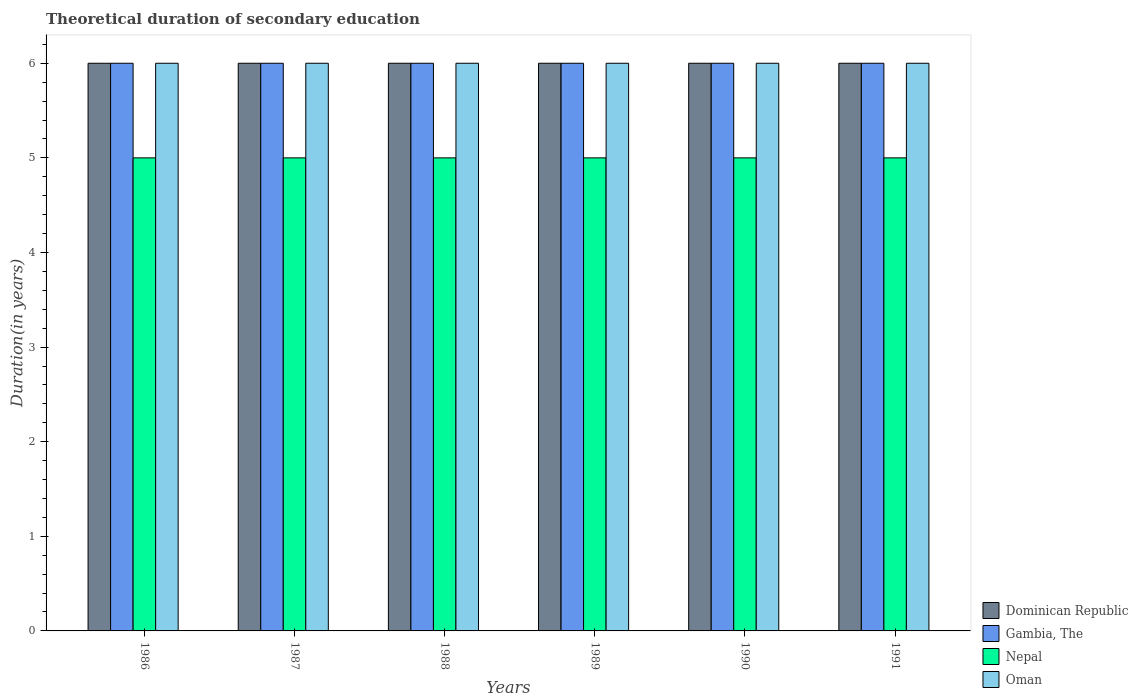How many different coloured bars are there?
Offer a very short reply. 4. How many groups of bars are there?
Ensure brevity in your answer.  6. How many bars are there on the 6th tick from the right?
Your response must be concise. 4. What is the label of the 6th group of bars from the left?
Keep it short and to the point. 1991. What is the total theoretical duration of secondary education in Gambia, The in 1990?
Make the answer very short. 6. Across all years, what is the maximum total theoretical duration of secondary education in Nepal?
Provide a succinct answer. 5. In which year was the total theoretical duration of secondary education in Oman minimum?
Ensure brevity in your answer.  1986. What is the total total theoretical duration of secondary education in Nepal in the graph?
Your answer should be compact. 30. What is the difference between the total theoretical duration of secondary education in Dominican Republic in 1987 and the total theoretical duration of secondary education in Nepal in 1990?
Make the answer very short. 1. What is the average total theoretical duration of secondary education in Dominican Republic per year?
Provide a succinct answer. 6. In the year 1986, what is the difference between the total theoretical duration of secondary education in Oman and total theoretical duration of secondary education in Nepal?
Provide a succinct answer. 1. In how many years, is the total theoretical duration of secondary education in Nepal greater than 4.2 years?
Offer a very short reply. 6. Is the total theoretical duration of secondary education in Nepal in 1986 less than that in 1988?
Your answer should be compact. No. What is the difference between the highest and the second highest total theoretical duration of secondary education in Oman?
Your answer should be compact. 0. What is the difference between the highest and the lowest total theoretical duration of secondary education in Gambia, The?
Your answer should be compact. 0. In how many years, is the total theoretical duration of secondary education in Nepal greater than the average total theoretical duration of secondary education in Nepal taken over all years?
Ensure brevity in your answer.  0. Is the sum of the total theoretical duration of secondary education in Dominican Republic in 1986 and 1988 greater than the maximum total theoretical duration of secondary education in Gambia, The across all years?
Your answer should be compact. Yes. What does the 4th bar from the left in 1991 represents?
Your answer should be compact. Oman. What does the 3rd bar from the right in 1990 represents?
Your answer should be compact. Gambia, The. How many bars are there?
Provide a short and direct response. 24. Are all the bars in the graph horizontal?
Provide a short and direct response. No. How many years are there in the graph?
Give a very brief answer. 6. Does the graph contain any zero values?
Your answer should be very brief. No. How are the legend labels stacked?
Give a very brief answer. Vertical. What is the title of the graph?
Give a very brief answer. Theoretical duration of secondary education. What is the label or title of the X-axis?
Make the answer very short. Years. What is the label or title of the Y-axis?
Your answer should be very brief. Duration(in years). What is the Duration(in years) of Gambia, The in 1986?
Your answer should be very brief. 6. What is the Duration(in years) of Dominican Republic in 1987?
Offer a very short reply. 6. What is the Duration(in years) in Gambia, The in 1987?
Your answer should be very brief. 6. What is the Duration(in years) in Nepal in 1987?
Your response must be concise. 5. What is the Duration(in years) of Gambia, The in 1988?
Offer a terse response. 6. What is the Duration(in years) of Oman in 1988?
Keep it short and to the point. 6. What is the Duration(in years) in Gambia, The in 1989?
Your answer should be compact. 6. What is the Duration(in years) in Nepal in 1989?
Give a very brief answer. 5. What is the Duration(in years) in Oman in 1989?
Provide a succinct answer. 6. What is the Duration(in years) in Dominican Republic in 1990?
Offer a terse response. 6. What is the Duration(in years) in Gambia, The in 1990?
Provide a succinct answer. 6. What is the Duration(in years) in Nepal in 1991?
Give a very brief answer. 5. Across all years, what is the maximum Duration(in years) in Dominican Republic?
Offer a very short reply. 6. Across all years, what is the maximum Duration(in years) in Gambia, The?
Provide a short and direct response. 6. Across all years, what is the maximum Duration(in years) in Nepal?
Ensure brevity in your answer.  5. Across all years, what is the minimum Duration(in years) in Gambia, The?
Provide a short and direct response. 6. What is the total Duration(in years) in Gambia, The in the graph?
Offer a very short reply. 36. What is the total Duration(in years) in Oman in the graph?
Make the answer very short. 36. What is the difference between the Duration(in years) of Gambia, The in 1986 and that in 1987?
Offer a terse response. 0. What is the difference between the Duration(in years) in Oman in 1986 and that in 1987?
Your response must be concise. 0. What is the difference between the Duration(in years) in Dominican Republic in 1986 and that in 1988?
Ensure brevity in your answer.  0. What is the difference between the Duration(in years) in Gambia, The in 1986 and that in 1988?
Provide a short and direct response. 0. What is the difference between the Duration(in years) in Oman in 1986 and that in 1988?
Your answer should be very brief. 0. What is the difference between the Duration(in years) in Dominican Republic in 1986 and that in 1989?
Make the answer very short. 0. What is the difference between the Duration(in years) in Gambia, The in 1986 and that in 1989?
Make the answer very short. 0. What is the difference between the Duration(in years) in Oman in 1986 and that in 1989?
Your answer should be very brief. 0. What is the difference between the Duration(in years) of Dominican Republic in 1986 and that in 1990?
Provide a short and direct response. 0. What is the difference between the Duration(in years) in Nepal in 1986 and that in 1990?
Provide a succinct answer. 0. What is the difference between the Duration(in years) in Oman in 1986 and that in 1990?
Offer a terse response. 0. What is the difference between the Duration(in years) of Dominican Republic in 1986 and that in 1991?
Keep it short and to the point. 0. What is the difference between the Duration(in years) of Gambia, The in 1986 and that in 1991?
Your answer should be very brief. 0. What is the difference between the Duration(in years) of Dominican Republic in 1987 and that in 1989?
Ensure brevity in your answer.  0. What is the difference between the Duration(in years) of Gambia, The in 1987 and that in 1991?
Keep it short and to the point. 0. What is the difference between the Duration(in years) of Nepal in 1987 and that in 1991?
Make the answer very short. 0. What is the difference between the Duration(in years) of Oman in 1987 and that in 1991?
Your answer should be compact. 0. What is the difference between the Duration(in years) of Gambia, The in 1988 and that in 1989?
Keep it short and to the point. 0. What is the difference between the Duration(in years) in Gambia, The in 1988 and that in 1990?
Provide a short and direct response. 0. What is the difference between the Duration(in years) in Oman in 1988 and that in 1990?
Provide a short and direct response. 0. What is the difference between the Duration(in years) of Gambia, The in 1988 and that in 1991?
Offer a terse response. 0. What is the difference between the Duration(in years) in Oman in 1988 and that in 1991?
Your answer should be compact. 0. What is the difference between the Duration(in years) in Nepal in 1989 and that in 1990?
Your response must be concise. 0. What is the difference between the Duration(in years) of Oman in 1989 and that in 1991?
Your answer should be very brief. 0. What is the difference between the Duration(in years) of Dominican Republic in 1990 and that in 1991?
Make the answer very short. 0. What is the difference between the Duration(in years) in Gambia, The in 1990 and that in 1991?
Provide a succinct answer. 0. What is the difference between the Duration(in years) in Oman in 1990 and that in 1991?
Your response must be concise. 0. What is the difference between the Duration(in years) of Dominican Republic in 1986 and the Duration(in years) of Gambia, The in 1987?
Provide a short and direct response. 0. What is the difference between the Duration(in years) of Dominican Republic in 1986 and the Duration(in years) of Nepal in 1987?
Provide a short and direct response. 1. What is the difference between the Duration(in years) of Gambia, The in 1986 and the Duration(in years) of Nepal in 1987?
Make the answer very short. 1. What is the difference between the Duration(in years) in Nepal in 1986 and the Duration(in years) in Oman in 1987?
Your answer should be compact. -1. What is the difference between the Duration(in years) of Dominican Republic in 1986 and the Duration(in years) of Oman in 1988?
Ensure brevity in your answer.  0. What is the difference between the Duration(in years) in Gambia, The in 1986 and the Duration(in years) in Oman in 1988?
Provide a succinct answer. 0. What is the difference between the Duration(in years) in Nepal in 1986 and the Duration(in years) in Oman in 1988?
Give a very brief answer. -1. What is the difference between the Duration(in years) of Dominican Republic in 1986 and the Duration(in years) of Gambia, The in 1989?
Provide a succinct answer. 0. What is the difference between the Duration(in years) of Gambia, The in 1986 and the Duration(in years) of Oman in 1990?
Give a very brief answer. 0. What is the difference between the Duration(in years) in Dominican Republic in 1986 and the Duration(in years) in Gambia, The in 1991?
Your response must be concise. 0. What is the difference between the Duration(in years) in Dominican Republic in 1986 and the Duration(in years) in Nepal in 1991?
Ensure brevity in your answer.  1. What is the difference between the Duration(in years) in Gambia, The in 1986 and the Duration(in years) in Oman in 1991?
Offer a very short reply. 0. What is the difference between the Duration(in years) of Nepal in 1986 and the Duration(in years) of Oman in 1991?
Provide a short and direct response. -1. What is the difference between the Duration(in years) of Dominican Republic in 1987 and the Duration(in years) of Gambia, The in 1988?
Keep it short and to the point. 0. What is the difference between the Duration(in years) of Dominican Republic in 1987 and the Duration(in years) of Nepal in 1988?
Your answer should be very brief. 1. What is the difference between the Duration(in years) in Dominican Republic in 1987 and the Duration(in years) in Oman in 1988?
Your answer should be compact. 0. What is the difference between the Duration(in years) of Gambia, The in 1987 and the Duration(in years) of Nepal in 1988?
Make the answer very short. 1. What is the difference between the Duration(in years) of Nepal in 1987 and the Duration(in years) of Oman in 1988?
Give a very brief answer. -1. What is the difference between the Duration(in years) of Dominican Republic in 1987 and the Duration(in years) of Nepal in 1989?
Keep it short and to the point. 1. What is the difference between the Duration(in years) in Dominican Republic in 1987 and the Duration(in years) in Oman in 1989?
Your answer should be very brief. 0. What is the difference between the Duration(in years) in Gambia, The in 1987 and the Duration(in years) in Oman in 1989?
Make the answer very short. 0. What is the difference between the Duration(in years) of Dominican Republic in 1987 and the Duration(in years) of Nepal in 1990?
Your answer should be compact. 1. What is the difference between the Duration(in years) of Dominican Republic in 1987 and the Duration(in years) of Oman in 1990?
Make the answer very short. 0. What is the difference between the Duration(in years) of Gambia, The in 1987 and the Duration(in years) of Oman in 1990?
Provide a succinct answer. 0. What is the difference between the Duration(in years) in Nepal in 1987 and the Duration(in years) in Oman in 1990?
Ensure brevity in your answer.  -1. What is the difference between the Duration(in years) in Gambia, The in 1987 and the Duration(in years) in Nepal in 1991?
Give a very brief answer. 1. What is the difference between the Duration(in years) of Dominican Republic in 1988 and the Duration(in years) of Gambia, The in 1989?
Make the answer very short. 0. What is the difference between the Duration(in years) of Dominican Republic in 1988 and the Duration(in years) of Oman in 1989?
Provide a succinct answer. 0. What is the difference between the Duration(in years) of Gambia, The in 1988 and the Duration(in years) of Oman in 1989?
Keep it short and to the point. 0. What is the difference between the Duration(in years) of Dominican Republic in 1988 and the Duration(in years) of Gambia, The in 1990?
Offer a very short reply. 0. What is the difference between the Duration(in years) in Dominican Republic in 1988 and the Duration(in years) in Oman in 1990?
Provide a short and direct response. 0. What is the difference between the Duration(in years) in Gambia, The in 1988 and the Duration(in years) in Nepal in 1990?
Provide a succinct answer. 1. What is the difference between the Duration(in years) of Nepal in 1988 and the Duration(in years) of Oman in 1990?
Your response must be concise. -1. What is the difference between the Duration(in years) in Nepal in 1988 and the Duration(in years) in Oman in 1991?
Your answer should be very brief. -1. What is the difference between the Duration(in years) of Gambia, The in 1989 and the Duration(in years) of Nepal in 1990?
Your answer should be very brief. 1. What is the difference between the Duration(in years) of Gambia, The in 1989 and the Duration(in years) of Oman in 1990?
Keep it short and to the point. 0. What is the difference between the Duration(in years) of Dominican Republic in 1989 and the Duration(in years) of Gambia, The in 1991?
Keep it short and to the point. 0. What is the difference between the Duration(in years) of Dominican Republic in 1989 and the Duration(in years) of Nepal in 1991?
Ensure brevity in your answer.  1. What is the difference between the Duration(in years) of Dominican Republic in 1989 and the Duration(in years) of Oman in 1991?
Keep it short and to the point. 0. What is the difference between the Duration(in years) of Gambia, The in 1989 and the Duration(in years) of Nepal in 1991?
Provide a succinct answer. 1. What is the difference between the Duration(in years) in Gambia, The in 1989 and the Duration(in years) in Oman in 1991?
Provide a short and direct response. 0. What is the difference between the Duration(in years) in Nepal in 1989 and the Duration(in years) in Oman in 1991?
Offer a very short reply. -1. What is the difference between the Duration(in years) of Dominican Republic in 1990 and the Duration(in years) of Gambia, The in 1991?
Ensure brevity in your answer.  0. What is the difference between the Duration(in years) of Dominican Republic in 1990 and the Duration(in years) of Nepal in 1991?
Make the answer very short. 1. What is the difference between the Duration(in years) in Gambia, The in 1990 and the Duration(in years) in Nepal in 1991?
Your answer should be compact. 1. What is the difference between the Duration(in years) of Nepal in 1990 and the Duration(in years) of Oman in 1991?
Ensure brevity in your answer.  -1. What is the average Duration(in years) in Gambia, The per year?
Ensure brevity in your answer.  6. What is the average Duration(in years) in Nepal per year?
Ensure brevity in your answer.  5. In the year 1986, what is the difference between the Duration(in years) in Dominican Republic and Duration(in years) in Oman?
Your response must be concise. 0. In the year 1986, what is the difference between the Duration(in years) in Gambia, The and Duration(in years) in Nepal?
Make the answer very short. 1. In the year 1986, what is the difference between the Duration(in years) of Nepal and Duration(in years) of Oman?
Provide a short and direct response. -1. In the year 1987, what is the difference between the Duration(in years) in Dominican Republic and Duration(in years) in Nepal?
Provide a short and direct response. 1. In the year 1987, what is the difference between the Duration(in years) in Gambia, The and Duration(in years) in Nepal?
Offer a very short reply. 1. In the year 1987, what is the difference between the Duration(in years) of Gambia, The and Duration(in years) of Oman?
Provide a succinct answer. 0. In the year 1987, what is the difference between the Duration(in years) in Nepal and Duration(in years) in Oman?
Offer a very short reply. -1. In the year 1988, what is the difference between the Duration(in years) of Dominican Republic and Duration(in years) of Nepal?
Offer a very short reply. 1. In the year 1988, what is the difference between the Duration(in years) of Nepal and Duration(in years) of Oman?
Ensure brevity in your answer.  -1. In the year 1989, what is the difference between the Duration(in years) in Dominican Republic and Duration(in years) in Gambia, The?
Ensure brevity in your answer.  0. In the year 1989, what is the difference between the Duration(in years) of Dominican Republic and Duration(in years) of Nepal?
Your response must be concise. 1. In the year 1989, what is the difference between the Duration(in years) in Gambia, The and Duration(in years) in Nepal?
Your answer should be compact. 1. In the year 1989, what is the difference between the Duration(in years) in Gambia, The and Duration(in years) in Oman?
Provide a succinct answer. 0. In the year 1989, what is the difference between the Duration(in years) of Nepal and Duration(in years) of Oman?
Provide a short and direct response. -1. In the year 1990, what is the difference between the Duration(in years) in Dominican Republic and Duration(in years) in Gambia, The?
Offer a very short reply. 0. In the year 1990, what is the difference between the Duration(in years) in Dominican Republic and Duration(in years) in Nepal?
Give a very brief answer. 1. In the year 1990, what is the difference between the Duration(in years) of Dominican Republic and Duration(in years) of Oman?
Your response must be concise. 0. In the year 1990, what is the difference between the Duration(in years) of Gambia, The and Duration(in years) of Nepal?
Offer a very short reply. 1. In the year 1990, what is the difference between the Duration(in years) in Gambia, The and Duration(in years) in Oman?
Offer a very short reply. 0. In the year 1990, what is the difference between the Duration(in years) of Nepal and Duration(in years) of Oman?
Offer a very short reply. -1. In the year 1991, what is the difference between the Duration(in years) in Dominican Republic and Duration(in years) in Nepal?
Your answer should be compact. 1. In the year 1991, what is the difference between the Duration(in years) in Dominican Republic and Duration(in years) in Oman?
Your answer should be very brief. 0. In the year 1991, what is the difference between the Duration(in years) of Gambia, The and Duration(in years) of Nepal?
Provide a short and direct response. 1. In the year 1991, what is the difference between the Duration(in years) in Gambia, The and Duration(in years) in Oman?
Provide a short and direct response. 0. In the year 1991, what is the difference between the Duration(in years) of Nepal and Duration(in years) of Oman?
Give a very brief answer. -1. What is the ratio of the Duration(in years) in Dominican Republic in 1986 to that in 1987?
Provide a short and direct response. 1. What is the ratio of the Duration(in years) in Nepal in 1986 to that in 1987?
Offer a terse response. 1. What is the ratio of the Duration(in years) in Gambia, The in 1986 to that in 1988?
Provide a short and direct response. 1. What is the ratio of the Duration(in years) of Dominican Republic in 1986 to that in 1989?
Ensure brevity in your answer.  1. What is the ratio of the Duration(in years) of Nepal in 1986 to that in 1989?
Make the answer very short. 1. What is the ratio of the Duration(in years) of Dominican Republic in 1986 to that in 1990?
Your answer should be very brief. 1. What is the ratio of the Duration(in years) in Oman in 1986 to that in 1990?
Your response must be concise. 1. What is the ratio of the Duration(in years) of Dominican Republic in 1986 to that in 1991?
Your answer should be compact. 1. What is the ratio of the Duration(in years) of Gambia, The in 1987 to that in 1988?
Keep it short and to the point. 1. What is the ratio of the Duration(in years) of Nepal in 1987 to that in 1988?
Provide a succinct answer. 1. What is the ratio of the Duration(in years) in Oman in 1987 to that in 1988?
Keep it short and to the point. 1. What is the ratio of the Duration(in years) of Dominican Republic in 1987 to that in 1989?
Give a very brief answer. 1. What is the ratio of the Duration(in years) in Gambia, The in 1987 to that in 1989?
Provide a short and direct response. 1. What is the ratio of the Duration(in years) of Nepal in 1987 to that in 1989?
Give a very brief answer. 1. What is the ratio of the Duration(in years) in Dominican Republic in 1987 to that in 1990?
Offer a terse response. 1. What is the ratio of the Duration(in years) of Gambia, The in 1987 to that in 1990?
Give a very brief answer. 1. What is the ratio of the Duration(in years) in Nepal in 1987 to that in 1991?
Your answer should be very brief. 1. What is the ratio of the Duration(in years) of Oman in 1987 to that in 1991?
Offer a terse response. 1. What is the ratio of the Duration(in years) in Dominican Republic in 1988 to that in 1989?
Provide a succinct answer. 1. What is the ratio of the Duration(in years) in Gambia, The in 1988 to that in 1989?
Provide a succinct answer. 1. What is the ratio of the Duration(in years) in Nepal in 1988 to that in 1989?
Your answer should be very brief. 1. What is the ratio of the Duration(in years) in Oman in 1988 to that in 1989?
Your answer should be compact. 1. What is the ratio of the Duration(in years) in Nepal in 1988 to that in 1990?
Ensure brevity in your answer.  1. What is the ratio of the Duration(in years) of Dominican Republic in 1988 to that in 1991?
Make the answer very short. 1. What is the ratio of the Duration(in years) in Dominican Republic in 1989 to that in 1990?
Your response must be concise. 1. What is the ratio of the Duration(in years) of Nepal in 1989 to that in 1990?
Offer a very short reply. 1. What is the ratio of the Duration(in years) of Dominican Republic in 1989 to that in 1991?
Ensure brevity in your answer.  1. What is the ratio of the Duration(in years) in Gambia, The in 1989 to that in 1991?
Your response must be concise. 1. What is the ratio of the Duration(in years) in Oman in 1989 to that in 1991?
Offer a very short reply. 1. What is the ratio of the Duration(in years) in Dominican Republic in 1990 to that in 1991?
Provide a succinct answer. 1. What is the difference between the highest and the second highest Duration(in years) of Dominican Republic?
Provide a short and direct response. 0. What is the difference between the highest and the second highest Duration(in years) of Gambia, The?
Make the answer very short. 0. What is the difference between the highest and the second highest Duration(in years) of Nepal?
Offer a very short reply. 0. What is the difference between the highest and the second highest Duration(in years) in Oman?
Offer a terse response. 0. What is the difference between the highest and the lowest Duration(in years) of Dominican Republic?
Keep it short and to the point. 0. What is the difference between the highest and the lowest Duration(in years) of Gambia, The?
Keep it short and to the point. 0. 